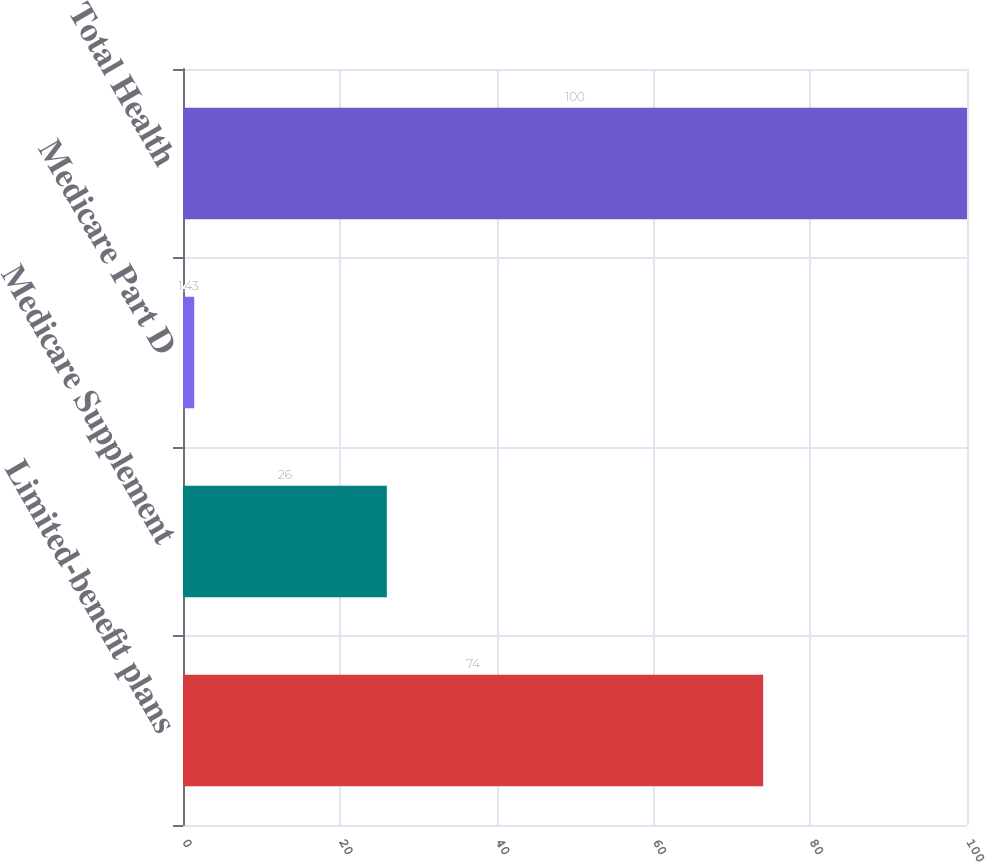Convert chart to OTSL. <chart><loc_0><loc_0><loc_500><loc_500><bar_chart><fcel>Limited-benefit plans<fcel>Medicare Supplement<fcel>Medicare Part D<fcel>Total Health<nl><fcel>74<fcel>26<fcel>1.43<fcel>100<nl></chart> 